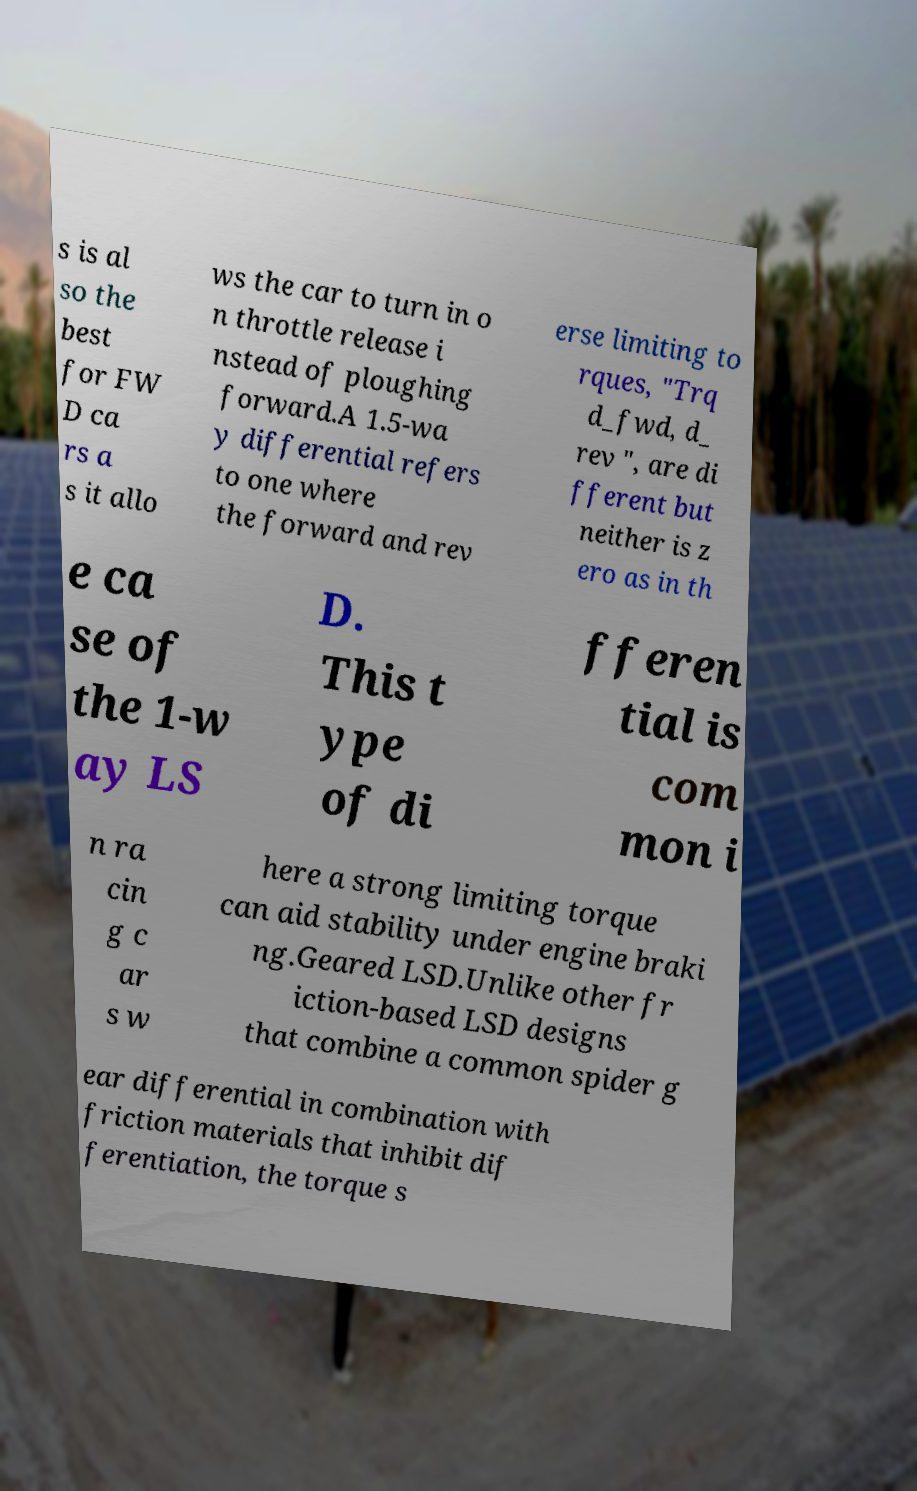Could you extract and type out the text from this image? s is al so the best for FW D ca rs a s it allo ws the car to turn in o n throttle release i nstead of ploughing forward.A 1.5-wa y differential refers to one where the forward and rev erse limiting to rques, "Trq d_fwd, d_ rev ", are di fferent but neither is z ero as in th e ca se of the 1-w ay LS D. This t ype of di fferen tial is com mon i n ra cin g c ar s w here a strong limiting torque can aid stability under engine braki ng.Geared LSD.Unlike other fr iction-based LSD designs that combine a common spider g ear differential in combination with friction materials that inhibit dif ferentiation, the torque s 